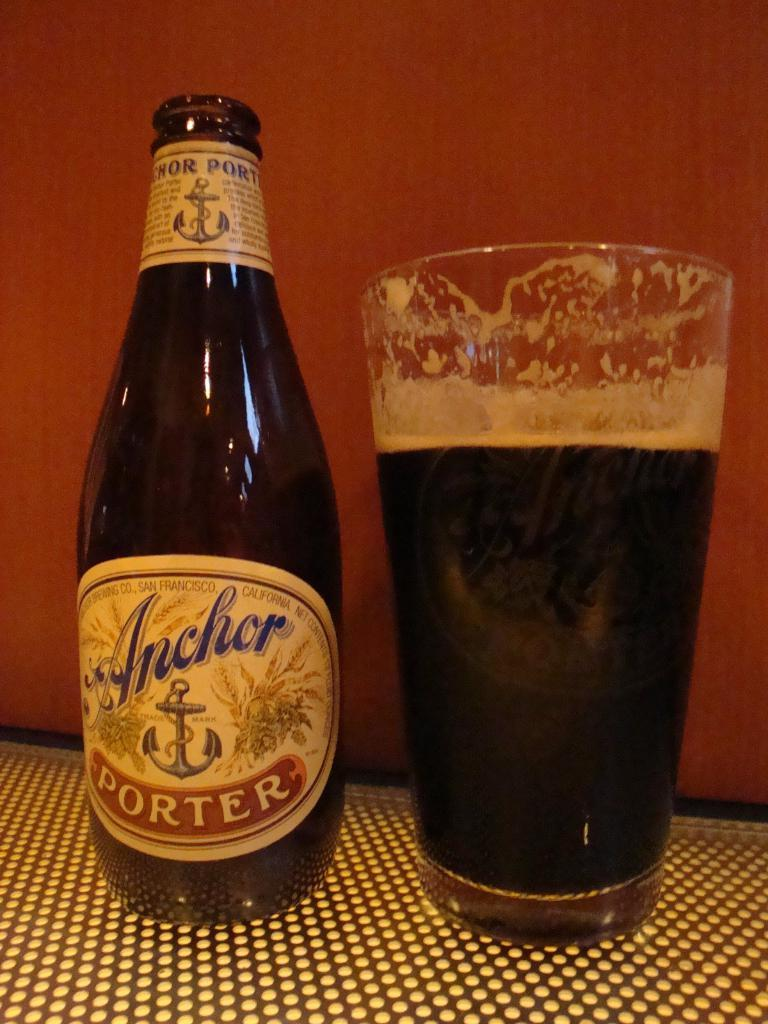<image>
Present a compact description of the photo's key features. a bottle of anchor porter next to a glass of it 